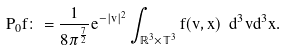Convert formula to latex. <formula><loc_0><loc_0><loc_500><loc_500>P _ { 0 } f \colon = \frac { 1 } { 8 \pi ^ { \frac { 7 } { 2 } } } e ^ { - | v | ^ { 2 } } \int _ { \mathbb { R } ^ { 3 } \times \mathbb { T } ^ { 3 } } f ( v , x ) \ d ^ { 3 } v d ^ { 3 } x .</formula> 